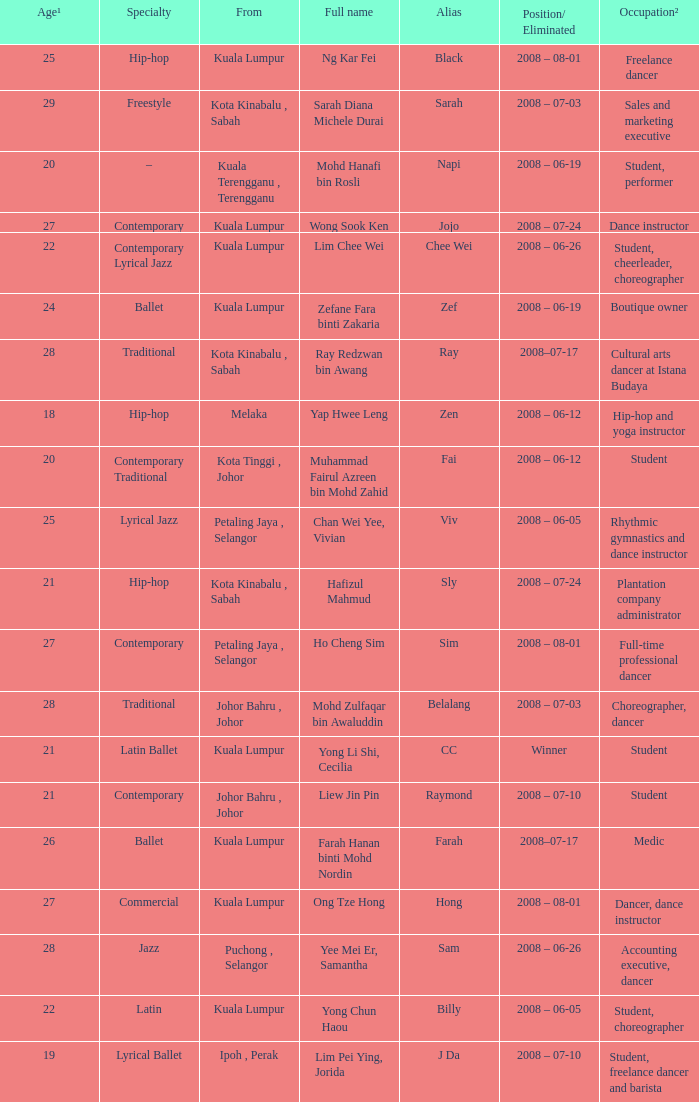What is Occupation², when Age¹ is greater than 24, when Alias is "Black"? Freelance dancer. 